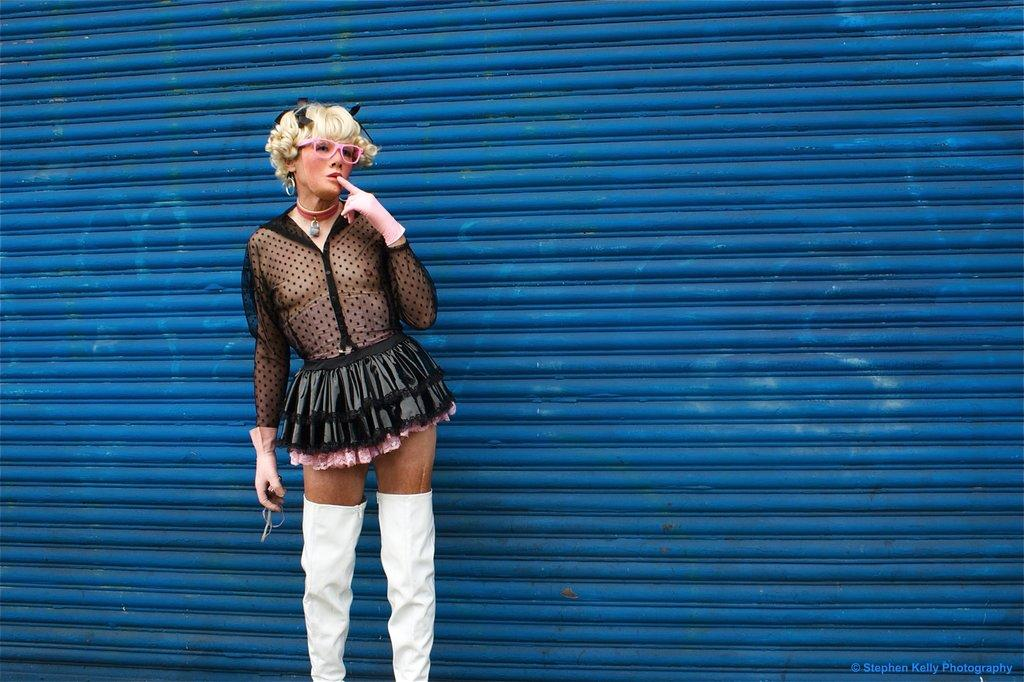What is the main subject of the image? There is a person standing in the image. What is the person doing in the image? The person is holding objects. What can be seen in the background of the image? There is a blue wall in the background of the image. What type of government is depicted in the image? There is no depiction of a government in the image; it features a person standing and holding objects with a blue wall in the background. 